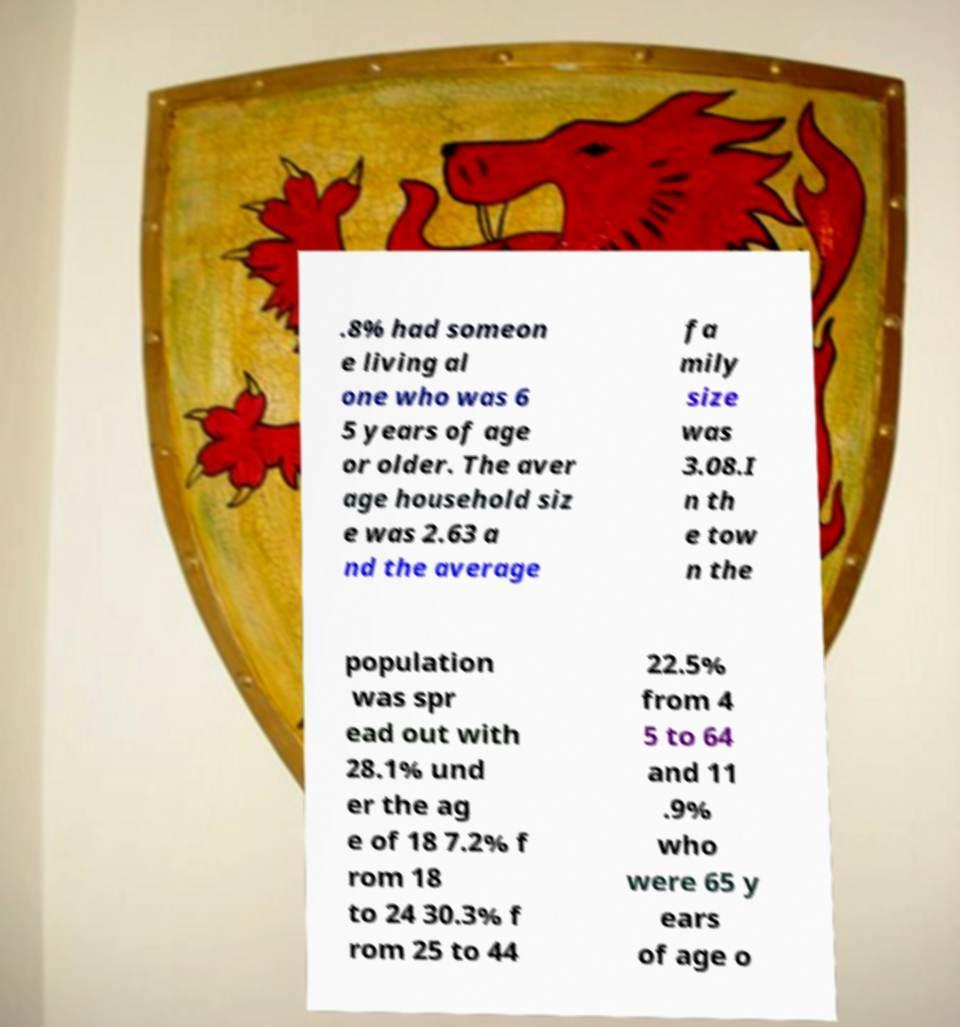Can you read and provide the text displayed in the image?This photo seems to have some interesting text. Can you extract and type it out for me? .8% had someon e living al one who was 6 5 years of age or older. The aver age household siz e was 2.63 a nd the average fa mily size was 3.08.I n th e tow n the population was spr ead out with 28.1% und er the ag e of 18 7.2% f rom 18 to 24 30.3% f rom 25 to 44 22.5% from 4 5 to 64 and 11 .9% who were 65 y ears of age o 